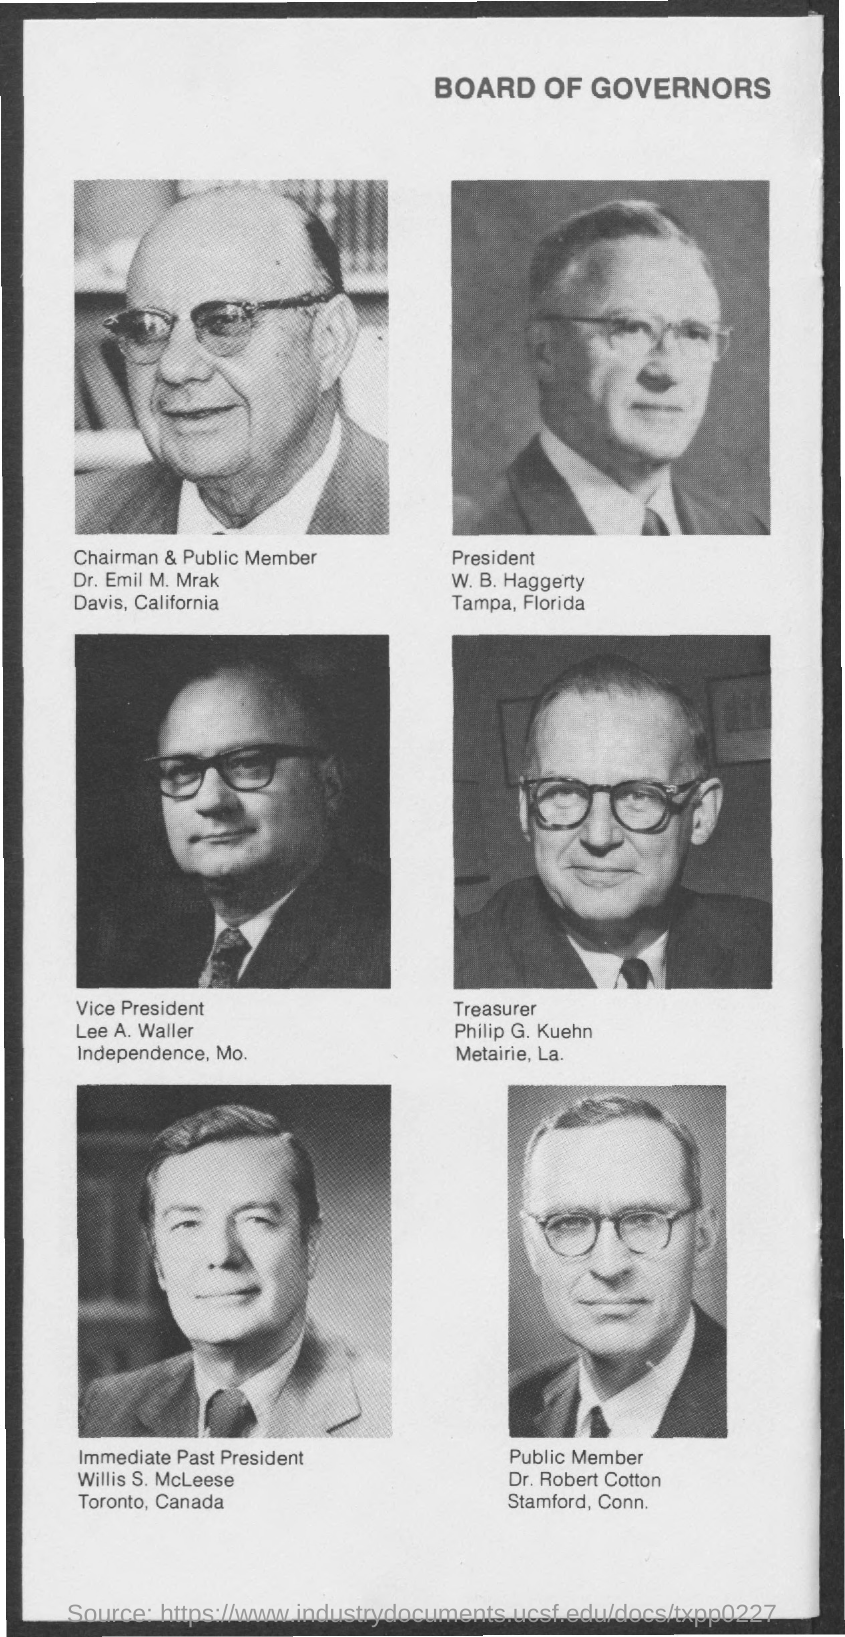Identify some key points in this picture. The treasurer's name is Philip G. Kuehn. The name of the chairman and the public member is Dr. Emil M. Mrak. The name of the president mentioned is Warren G. Harding. The public member mentioned is Dr. Robert Cotton. The immediate past president's name is Willis S. McLeese. 